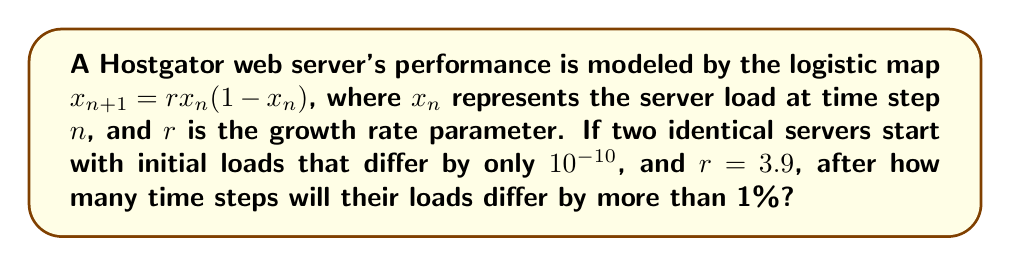Can you answer this question? To solve this problem, we need to understand the concept of sensitive dependence on initial conditions in chaos theory:

1. Let's denote the initial loads as $x_0$ and $y_0$, where $|x_0 - y_0| = 10^{-10}$.

2. We'll use the Lyapunov exponent $\lambda$ to measure the rate of separation between the two trajectories:

   $$\lambda = \lim_{n\to\infty} \frac{1}{n} \sum_{i=0}^{n-1} \ln |f'(x_i)|$$

3. For the logistic map, $f'(x) = r(1-2x)$. With $r=3.9$, we can approximate $\lambda$:

   $$\lambda \approx \ln 3.9 + \frac{1}{2} \ln(1-\frac{1}{3.9}) \approx 0.6946$$

4. The separation between trajectories grows exponentially:

   $$|x_n - y_n| \approx |x_0 - y_0|e^{\lambda n}$$

5. We want to find $n$ where $|x_n - y_n| > 0.01$:

   $$10^{-10}e^{0.6946n} > 0.01$$

6. Taking natural logarithms of both sides:

   $$\ln(10^{-10}) + 0.6946n > \ln(0.01)$$

7. Solving for $n$:

   $$n > \frac{\ln(0.01) - \ln(10^{-10})}{0.6946} \approx 28.9$$

8. Since $n$ must be an integer, we round up to the next whole number.
Answer: 29 time steps 